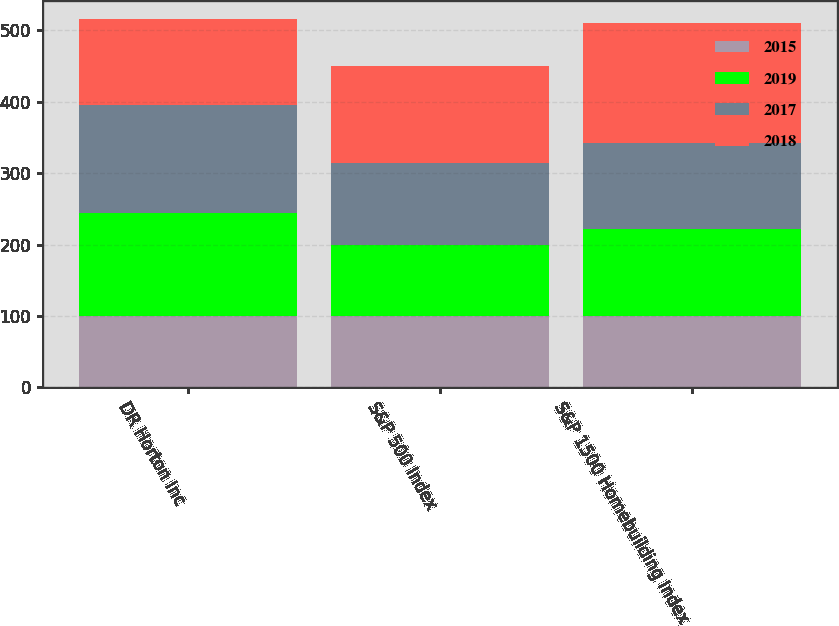Convert chart. <chart><loc_0><loc_0><loc_500><loc_500><stacked_bar_chart><ecel><fcel>DR Horton Inc<fcel>S&P 500 Index<fcel>S&P 1500 Homebuilding Index<nl><fcel>2015<fcel>100<fcel>100<fcel>100<nl><fcel>2019<fcel>144.45<fcel>99.39<fcel>121.48<nl><fcel>2017<fcel>150.18<fcel>114.72<fcel>120.76<nl><fcel>2018<fcel>120.76<fcel>136.07<fcel>167.16<nl></chart> 